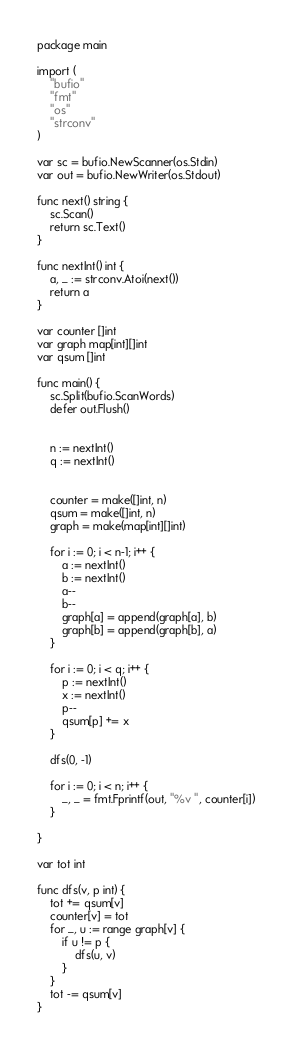<code> <loc_0><loc_0><loc_500><loc_500><_Go_>package main

import (
	"bufio"
	"fmt"
	"os"
	"strconv"
)

var sc = bufio.NewScanner(os.Stdin)
var out = bufio.NewWriter(os.Stdout)

func next() string {
	sc.Scan()
	return sc.Text()
}

func nextInt() int {
	a, _ := strconv.Atoi(next())
	return a
}

var counter []int
var graph map[int][]int
var qsum []int

func main() {
	sc.Split(bufio.ScanWords)
	defer out.Flush()


	n := nextInt()
	q := nextInt()


	counter = make([]int, n)
	qsum = make([]int, n)
	graph = make(map[int][]int)

	for i := 0; i < n-1; i++ {
		a := nextInt()
		b := nextInt()
		a--
		b--
		graph[a] = append(graph[a], b)
		graph[b] = append(graph[b], a)
	}

	for i := 0; i < q; i++ {
		p := nextInt()
		x := nextInt()
		p--
		qsum[p] += x
	}

	dfs(0, -1)

	for i := 0; i < n; i++ {
		_, _ = fmt.Fprintf(out, "%v ", counter[i])
	}

}

var tot int

func dfs(v, p int) {
	tot += qsum[v]
	counter[v] = tot
	for _, u := range graph[v] {
		if u != p {
			dfs(u, v)
		}
	}
	tot -= qsum[v]
}
</code> 